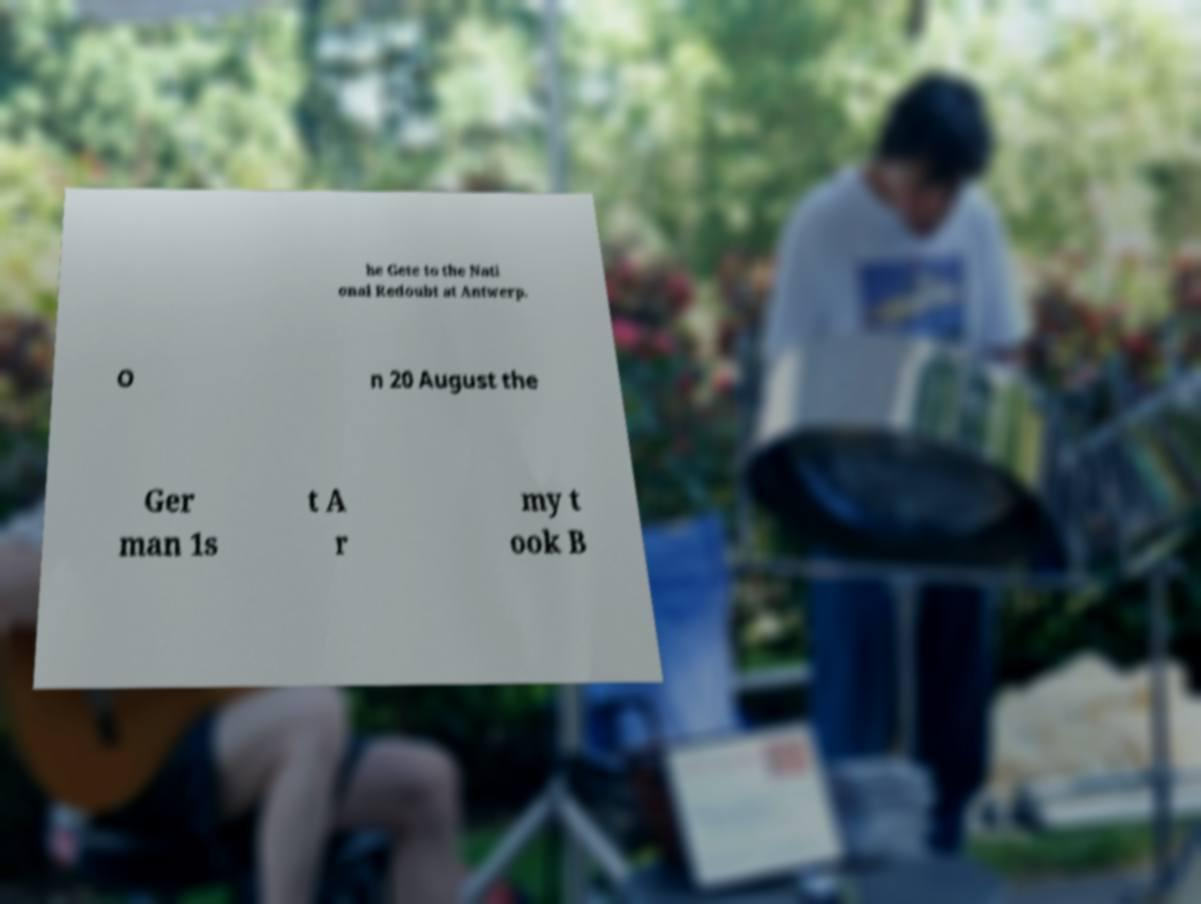Can you read and provide the text displayed in the image?This photo seems to have some interesting text. Can you extract and type it out for me? he Gete to the Nati onal Redoubt at Antwerp. O n 20 August the Ger man 1s t A r my t ook B 